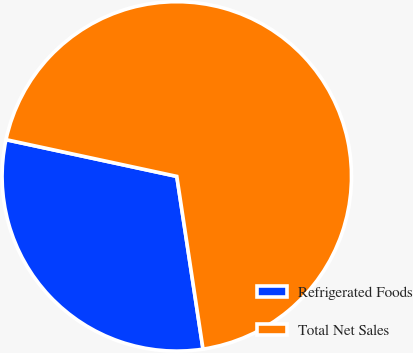Convert chart to OTSL. <chart><loc_0><loc_0><loc_500><loc_500><pie_chart><fcel>Refrigerated Foods<fcel>Total Net Sales<nl><fcel>30.77%<fcel>69.23%<nl></chart> 